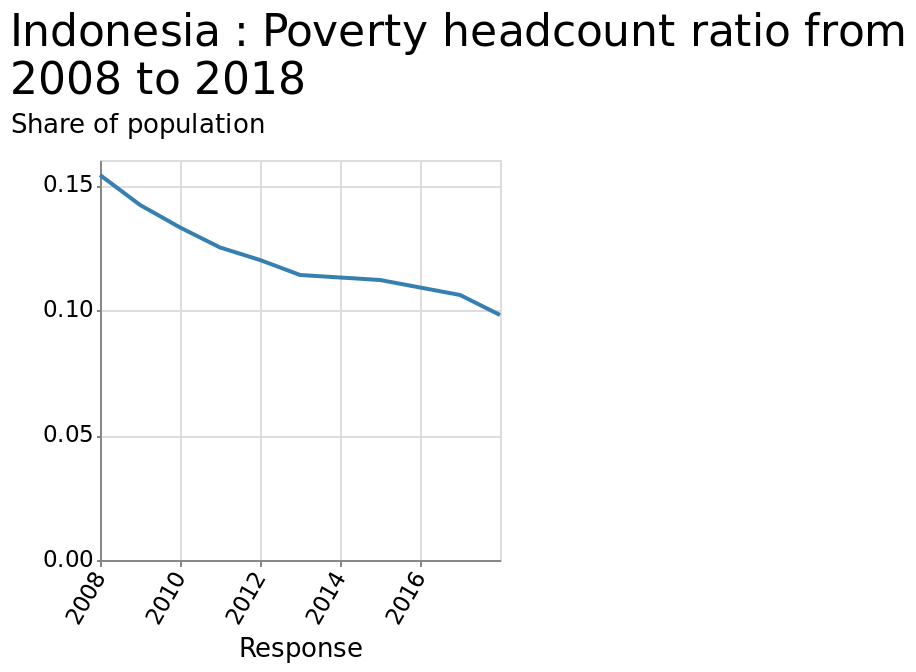<image>
What was the highest poverty headcount ratio in Indonesia in 2008? The highest poverty headcount ratio in Indonesia was above 0.15 in 2008. What is the range of values shown on the y-axis? The y-axis represents the share of population using a scale range from 0.00 to 0.15. What does the x-axis represent and what is the scale range?  The x-axis represents the response and it has a linear scale range from 2008 to 2016. 